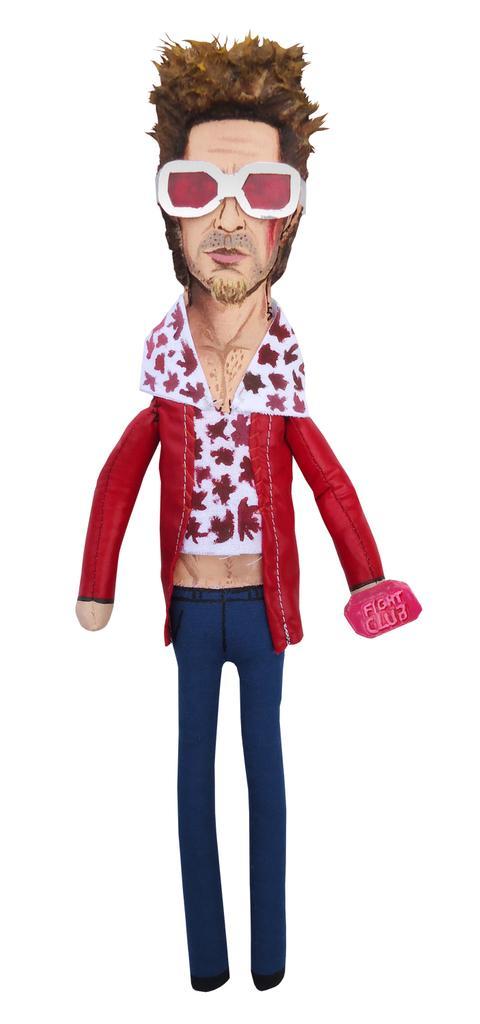How would you summarize this image in a sentence or two? In this image we can see a toy with white background. 